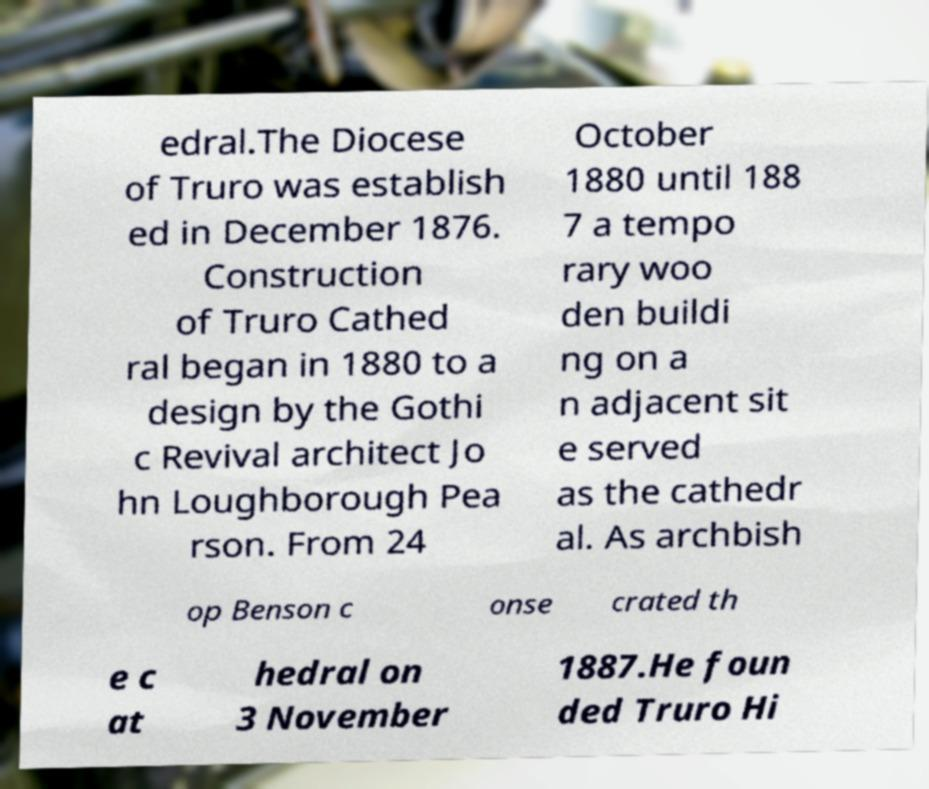Could you assist in decoding the text presented in this image and type it out clearly? edral.The Diocese of Truro was establish ed in December 1876. Construction of Truro Cathed ral began in 1880 to a design by the Gothi c Revival architect Jo hn Loughborough Pea rson. From 24 October 1880 until 188 7 a tempo rary woo den buildi ng on a n adjacent sit e served as the cathedr al. As archbish op Benson c onse crated th e c at hedral on 3 November 1887.He foun ded Truro Hi 